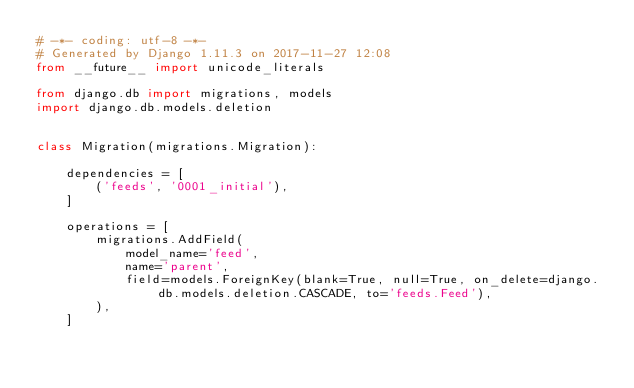Convert code to text. <code><loc_0><loc_0><loc_500><loc_500><_Python_># -*- coding: utf-8 -*-
# Generated by Django 1.11.3 on 2017-11-27 12:08
from __future__ import unicode_literals

from django.db import migrations, models
import django.db.models.deletion


class Migration(migrations.Migration):

    dependencies = [
        ('feeds', '0001_initial'),
    ]

    operations = [
        migrations.AddField(
            model_name='feed',
            name='parent',
            field=models.ForeignKey(blank=True, null=True, on_delete=django.db.models.deletion.CASCADE, to='feeds.Feed'),
        ),
    ]
</code> 